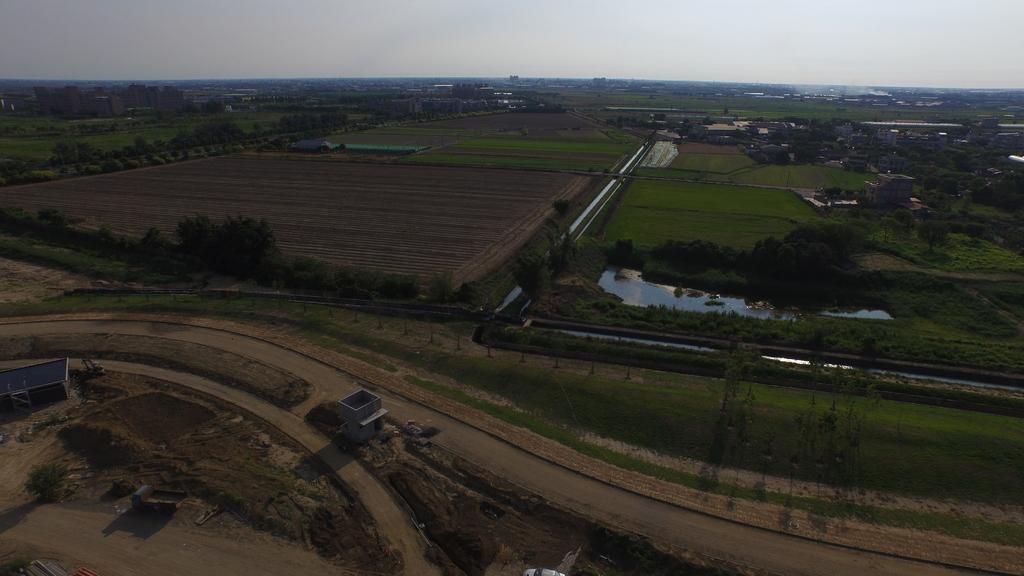Please provide a concise description of this image. In this image I can see grass, number of trees, number of buildings, few roads, water, smoke over there and I can see the sky in the background. 